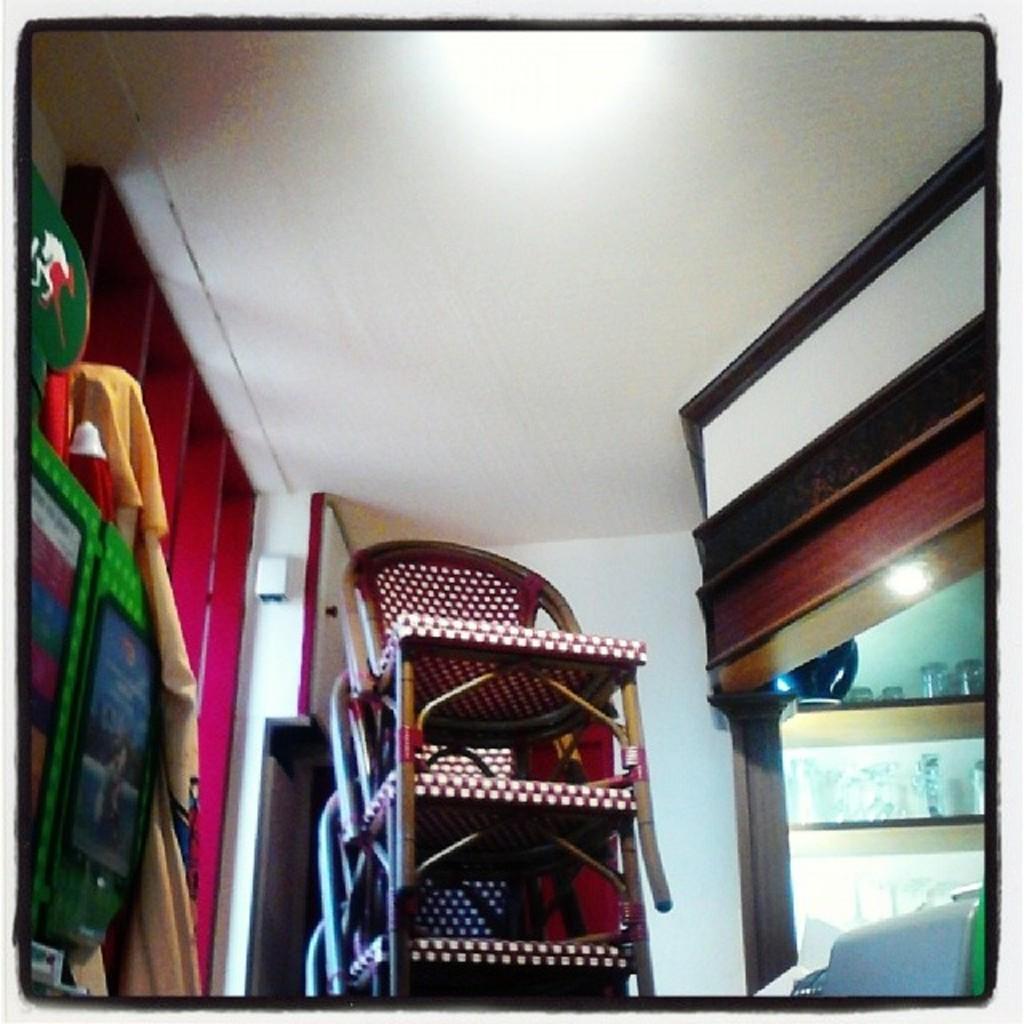How would you summarize this image in a sentence or two? In this picture we can see chairs, glasses in racks, clothes and in the background we can see the wall. 